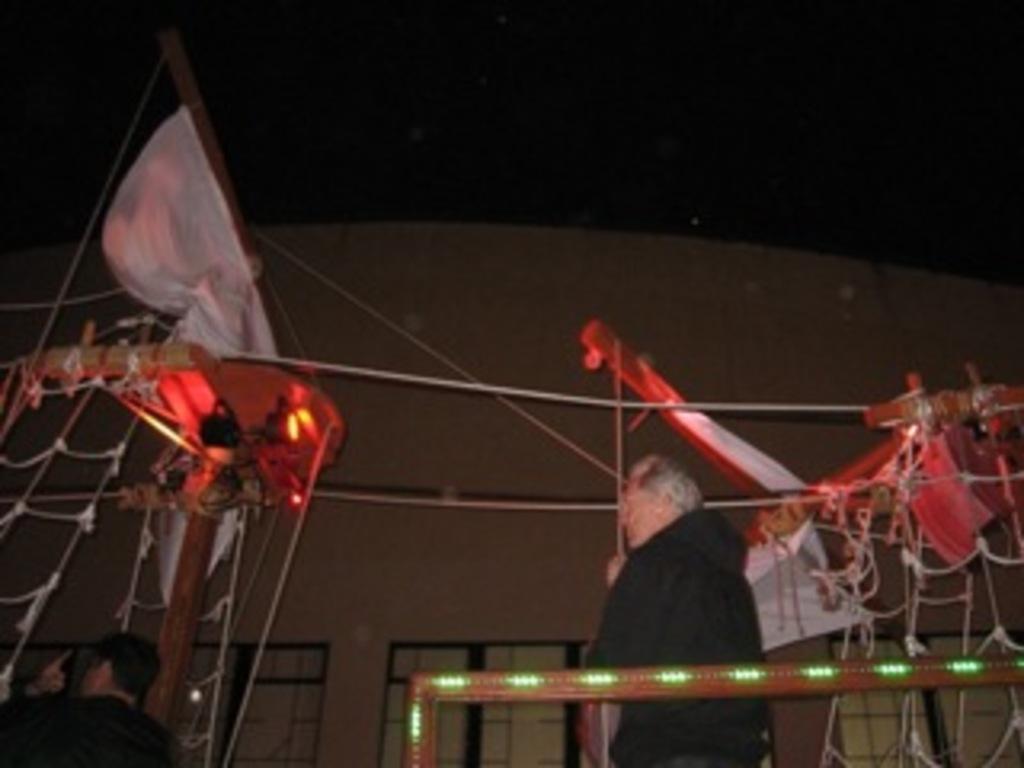Describe this image in one or two sentences. In this picture we can see 2 people standing and looking somewhere. Here the background is dark. 